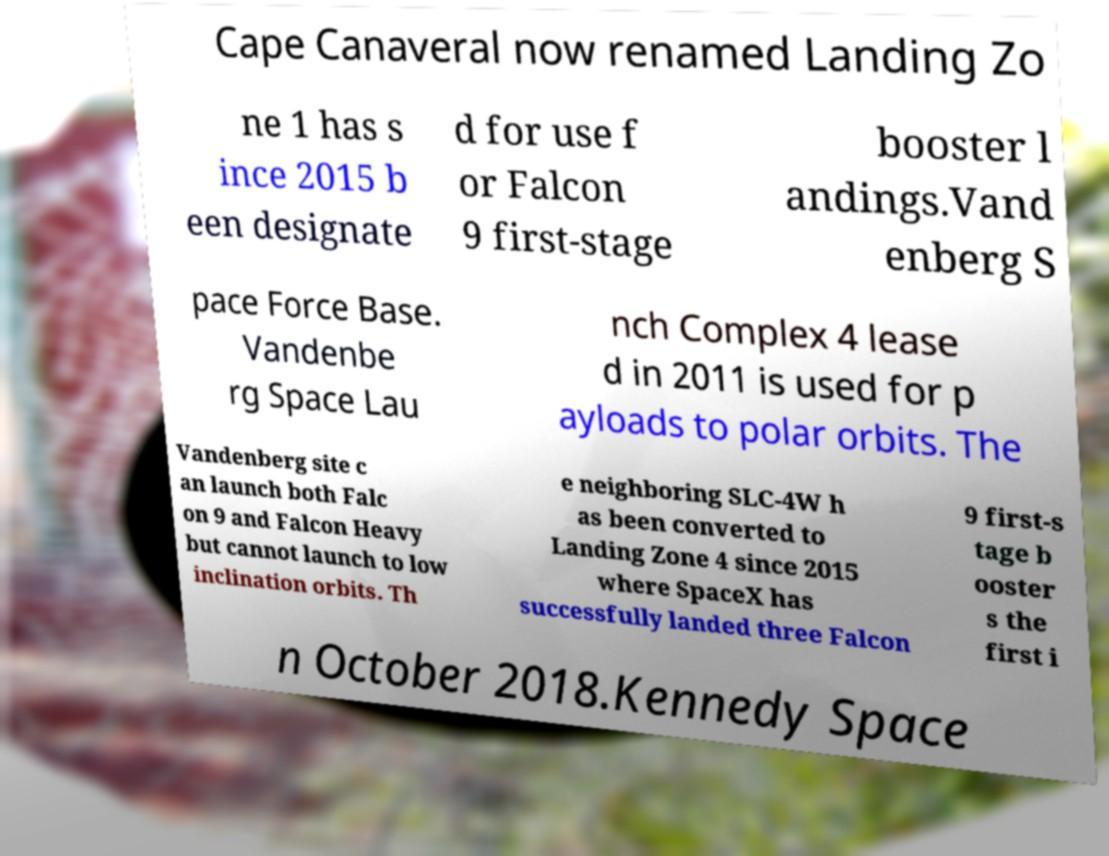Could you assist in decoding the text presented in this image and type it out clearly? Cape Canaveral now renamed Landing Zo ne 1 has s ince 2015 b een designate d for use f or Falcon 9 first-stage booster l andings.Vand enberg S pace Force Base. Vandenbe rg Space Lau nch Complex 4 lease d in 2011 is used for p ayloads to polar orbits. The Vandenberg site c an launch both Falc on 9 and Falcon Heavy but cannot launch to low inclination orbits. Th e neighboring SLC-4W h as been converted to Landing Zone 4 since 2015 where SpaceX has successfully landed three Falcon 9 first-s tage b ooster s the first i n October 2018.Kennedy Space 